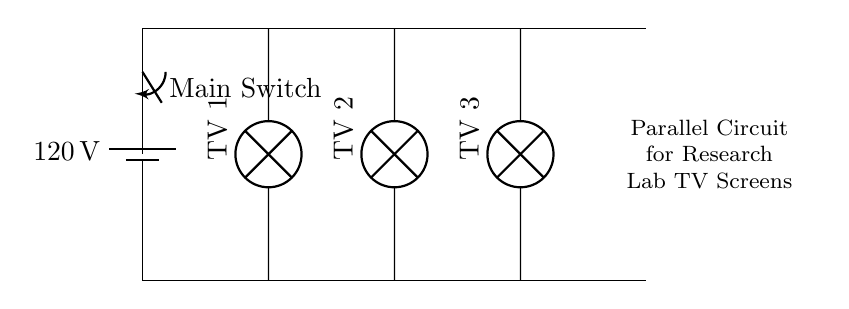What is the voltage supplied to the circuit? The circuit shows a battery with a label indicating the supplied voltage, which is 120 volts.
Answer: 120 volts How many TV screens are connected in the circuit? The diagram displays three lamps labeled as TV 1, TV 2, and TV 3, indicating three individual TV screens in parallel.
Answer: Three What happens when the main switch is turned off? The main switch interrupts the power flow from the battery to the circuit, resulting in all connected TV screens receiving no voltage and turning off.
Answer: All TVs turn off What type of circuit is used in this setup? The parallel connection design is evident as each TV screen has its own direct path to the power supply, allowing them to operate independently.
Answer: Parallel If one TV screen fails, what happens to the others? In a parallel circuit, if one component fails (like one TV screen), the other components (TV screens) continue to receive power and operate normally since each is connected independently.
Answer: Others continue to work What is the function of the switch in this circuit? The switch acts as a control mechanism allowing or interrupting the flow of electrical current from the battery to the entire circuit, effectively turning all TVs on or off simultaneously.
Answer: Control mechanism 